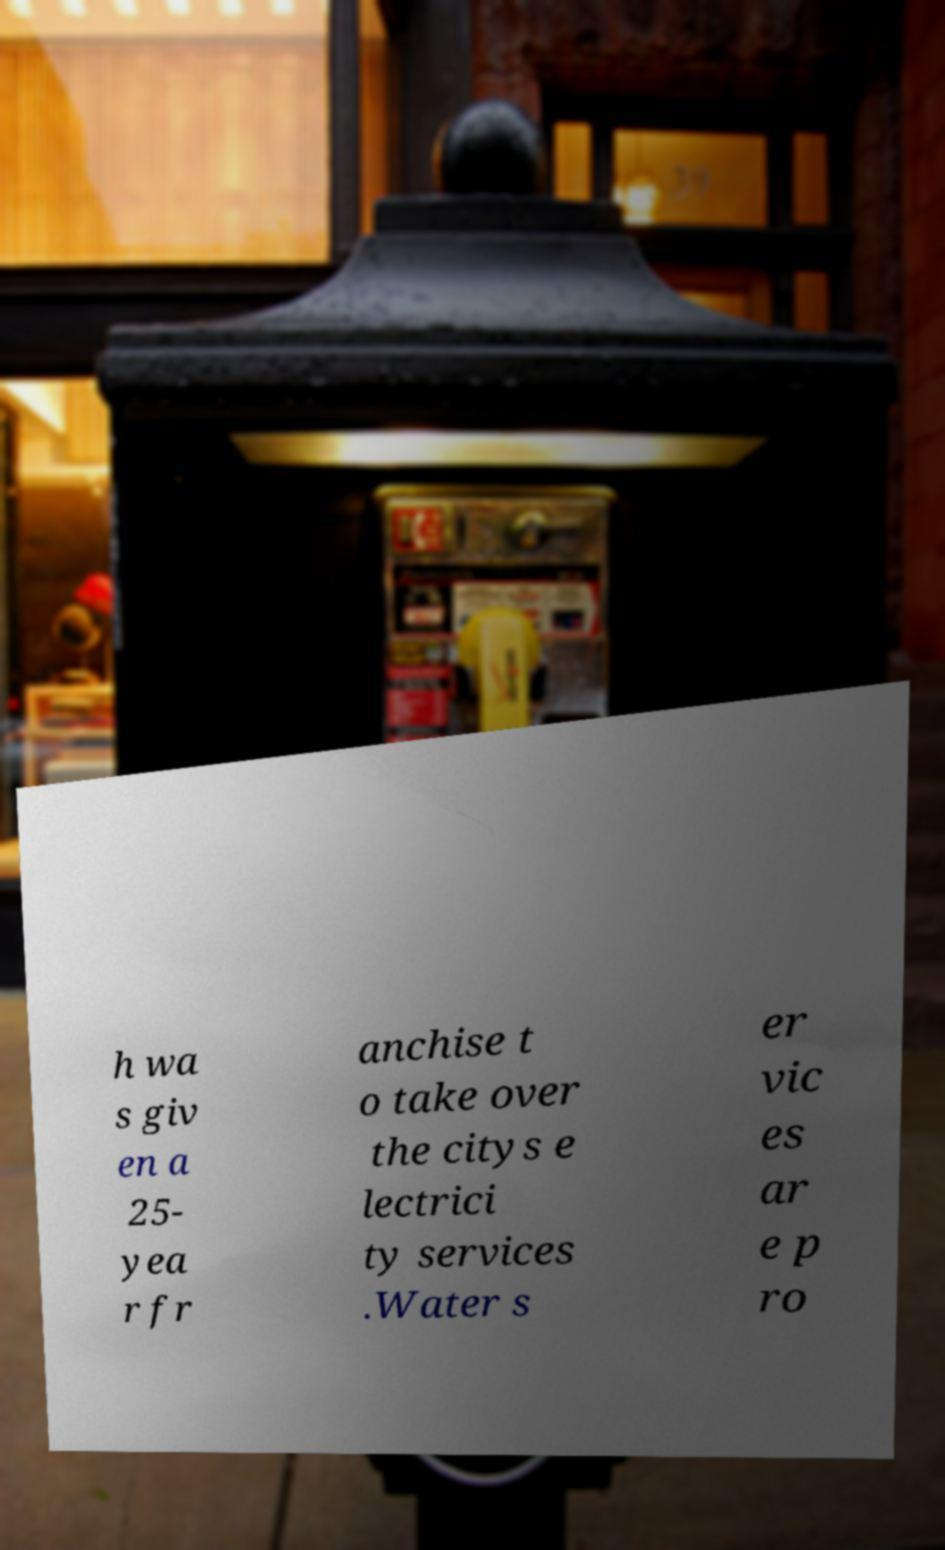Can you read and provide the text displayed in the image?This photo seems to have some interesting text. Can you extract and type it out for me? h wa s giv en a 25- yea r fr anchise t o take over the citys e lectrici ty services .Water s er vic es ar e p ro 